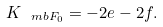Convert formula to latex. <formula><loc_0><loc_0><loc_500><loc_500>K _ { \ m b { F } _ { 0 } } = - 2 e - 2 f .</formula> 